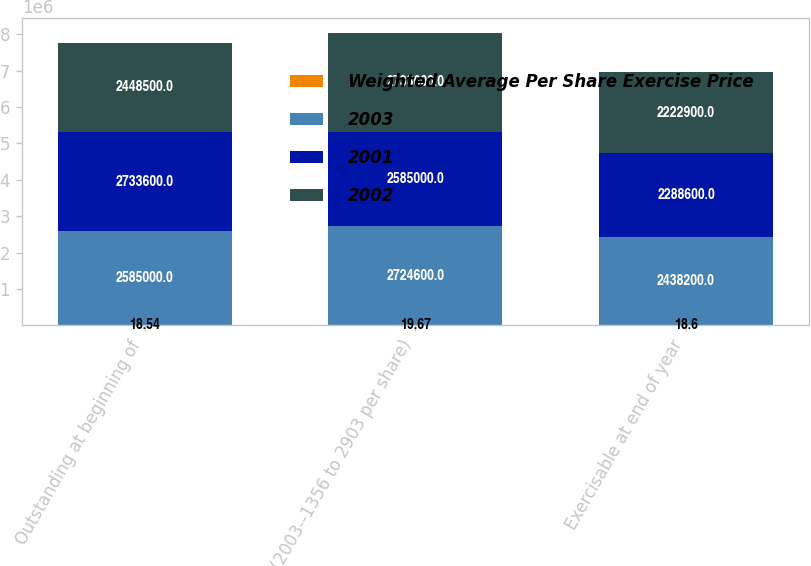Convert chart to OTSL. <chart><loc_0><loc_0><loc_500><loc_500><stacked_bar_chart><ecel><fcel>Outstanding at beginning of<fcel>(2003--1356 to 2903 per share)<fcel>Exercisable at end of year<nl><fcel>Weighted Average Per Share Exercise Price<fcel>18.54<fcel>19.67<fcel>18.6<nl><fcel>2003<fcel>2.585e+06<fcel>2.7246e+06<fcel>2.4382e+06<nl><fcel>2001<fcel>2.7336e+06<fcel>2.585e+06<fcel>2.2886e+06<nl><fcel>2002<fcel>2.4485e+06<fcel>2.7336e+06<fcel>2.2229e+06<nl></chart> 